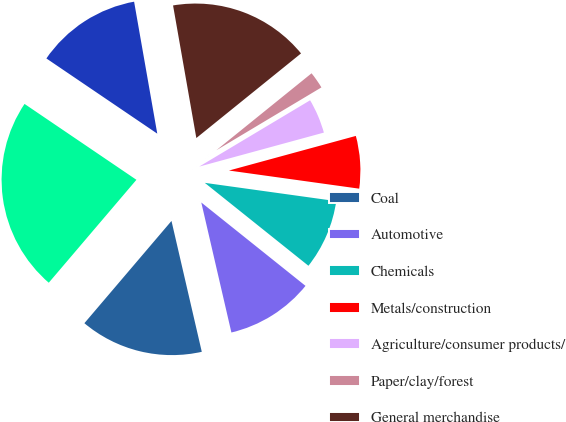Convert chart. <chart><loc_0><loc_0><loc_500><loc_500><pie_chart><fcel>Coal<fcel>Automotive<fcel>Chemicals<fcel>Metals/construction<fcel>Agriculture/consumer products/<fcel>Paper/clay/forest<fcel>General merchandise<fcel>Intermodal<fcel>Total<nl><fcel>14.85%<fcel>10.64%<fcel>8.54%<fcel>6.44%<fcel>4.34%<fcel>2.24%<fcel>16.95%<fcel>12.75%<fcel>23.26%<nl></chart> 